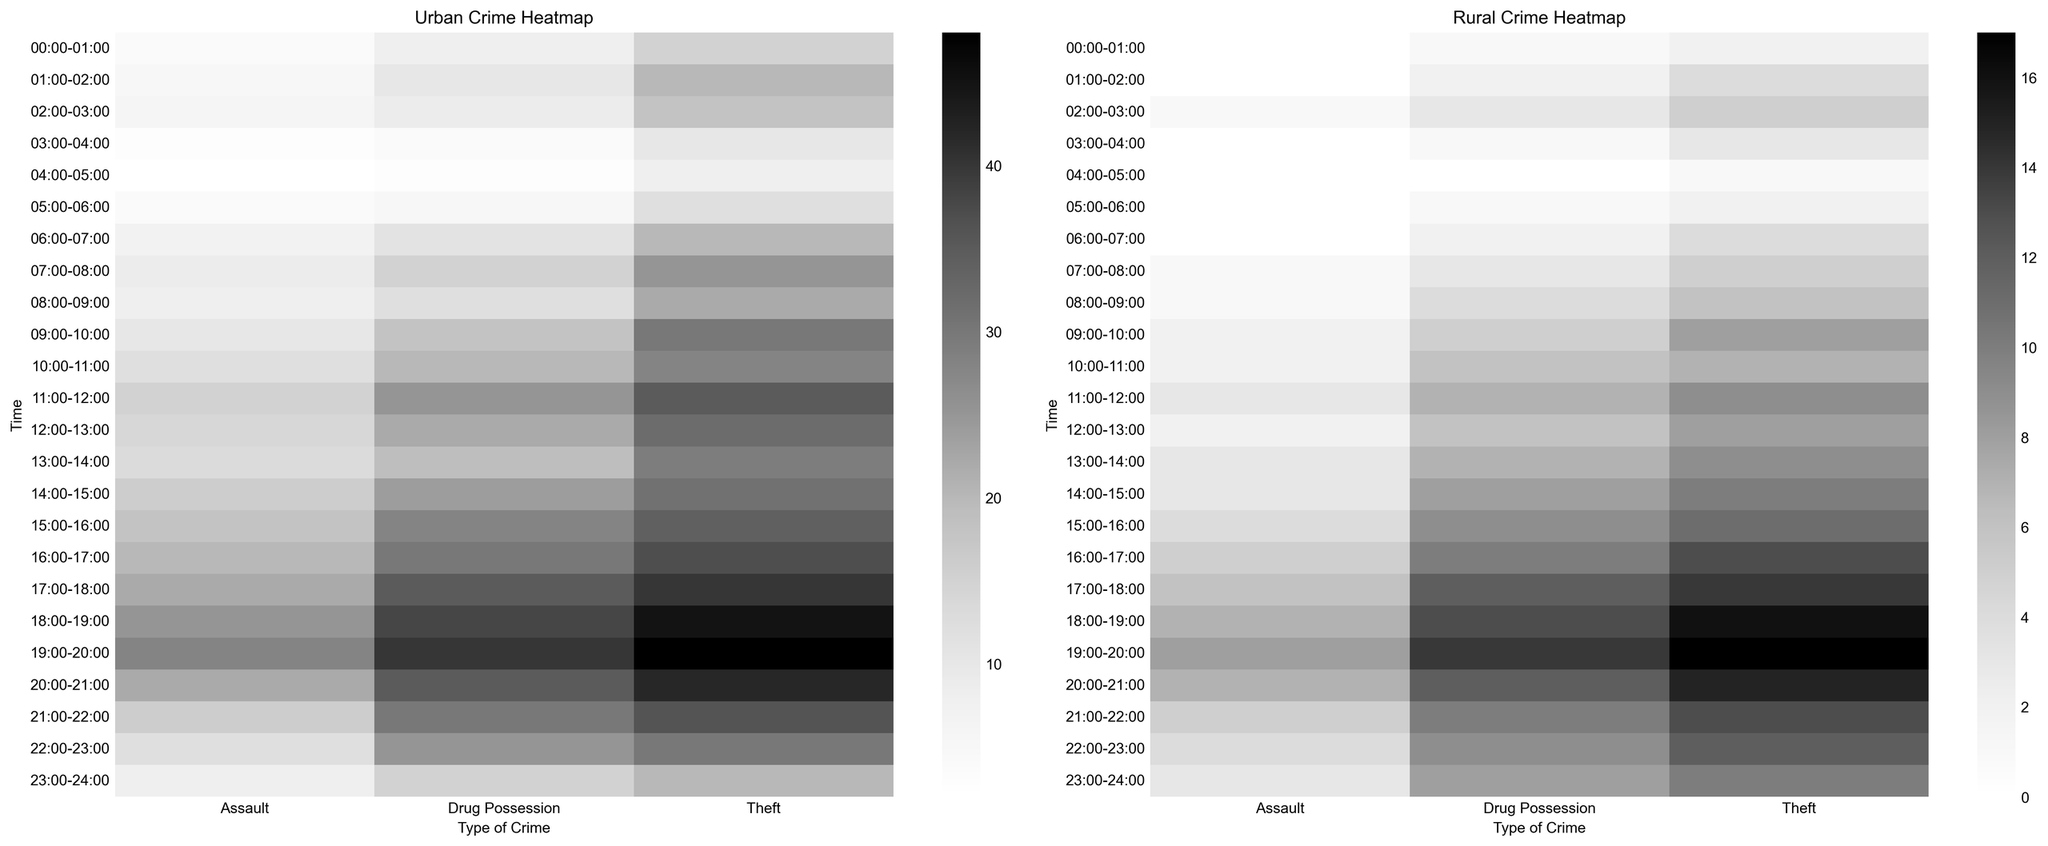What is the difference in the number of theft occurrences between urban and rural areas at 11:00-12:00? For urban areas at 11:00-12:00, there are 35 occurrences of theft. For rural areas at the same time, there are 9 occurrences of theft. The difference is 35 - 9 = 26
Answer: 26 Which area has a higher occurrence of drug possession at 20:00-21:00, urban or rural? By observing the heatmap, at 20:00-21:00 urban areas have 35 occurrences of drug possession, while rural areas have only 12 occurrences
Answer: Urban Between urban and rural areas, which has more theft occurrences overall at 23:00-24:00? At 23:00-24:00, urban areas have 20 occurrences of theft, while rural areas have 10 occurrences. Therefore, urban areas have more occurrences
Answer: Urban Which type of crime shows more significant visual difference between urban and rural areas during 15:00-16:00? Looking at the heatmap, theft in urban areas is denser with darker shades, indicating 34 occurrences. In contrast, rural areas have 11 occurrences, showing a substantial visual difference
Answer: Theft What is the average number of assault occurrences in urban areas between 16:00-18:00? For urban areas at 16:00-17:00, there are 20 occurrences of assault, and at 17:00-18:00, there are 22. The average is (20 + 22) / 2 = 21
Answer: 21 At which time is the discrepancy between urban and rural crime occurrences for drug possession the greatest? At 17:00-18:00, urban areas have 35 occurrences while rural areas have 12. Discrepancy is highest here, being 35 - 12 = 23
Answer: 17:00-18:00 How do the occurrences of assault during 03:00-04:00 in rural areas compare to urban areas? In rural areas at 03:00-04:00, assault occurrences are 0, while in urban areas, there are 3 occurrences. This shows more assault in urban areas at this time
Answer: Urban Calculate the total occurrences of theft in rural areas from 10:00-12:00. For rural areas, at 10:00-11:00 the occurrences are 7, and at 11:00-12:00 they are 9. Total occurrences in this period are 7 + 9 = 16
Answer: 16 What time slot shows equal occurrences of assaults in both urban and rural areas? At 16:00-17:00, both urban and rural areas have an equal number of assault occurrences, which is 5
Answer: 16:00-17:00 